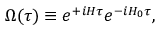<formula> <loc_0><loc_0><loc_500><loc_500>\Omega ( \tau ) \equiv e ^ { + i H \tau } e ^ { - i H _ { 0 } \tau } ,</formula> 